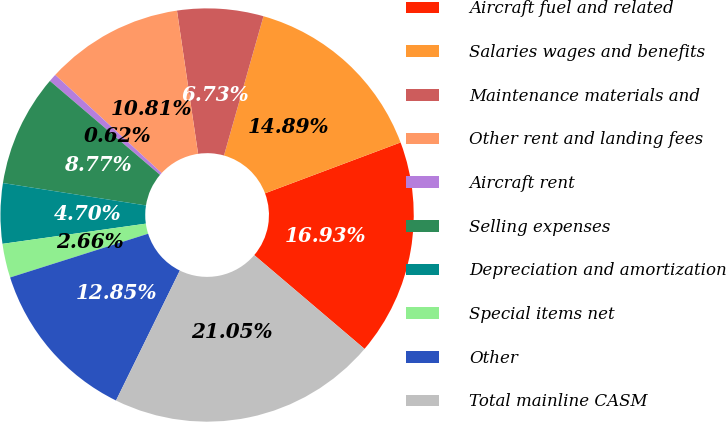Convert chart. <chart><loc_0><loc_0><loc_500><loc_500><pie_chart><fcel>Aircraft fuel and related<fcel>Salaries wages and benefits<fcel>Maintenance materials and<fcel>Other rent and landing fees<fcel>Aircraft rent<fcel>Selling expenses<fcel>Depreciation and amortization<fcel>Special items net<fcel>Other<fcel>Total mainline CASM<nl><fcel>16.93%<fcel>14.89%<fcel>6.73%<fcel>10.81%<fcel>0.62%<fcel>8.77%<fcel>4.7%<fcel>2.66%<fcel>12.85%<fcel>21.05%<nl></chart> 